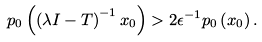<formula> <loc_0><loc_0><loc_500><loc_500>p _ { 0 } \left ( \left ( \lambda I - T \right ) ^ { - 1 } x _ { 0 } \right ) > 2 \epsilon ^ { - 1 } p _ { 0 } \left ( x _ { 0 } \right ) .</formula> 